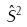Convert formula to latex. <formula><loc_0><loc_0><loc_500><loc_500>\hat { S } ^ { 2 }</formula> 